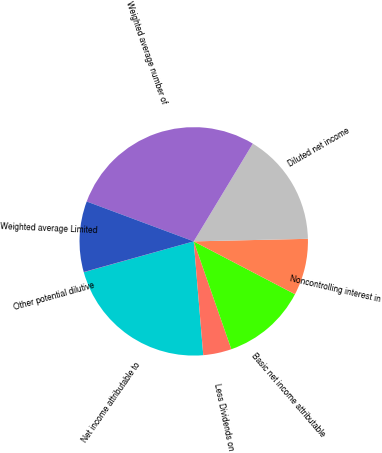Convert chart. <chart><loc_0><loc_0><loc_500><loc_500><pie_chart><fcel>Net income attributable to<fcel>Less Dividends on<fcel>Basic net income attributable<fcel>Noncontrolling interest in<fcel>Diluted net income<fcel>Weighted average number of<fcel>Weighted average Limited<fcel>Other potential dilutive<nl><fcel>21.98%<fcel>4.01%<fcel>12.0%<fcel>8.01%<fcel>15.99%<fcel>27.97%<fcel>10.0%<fcel>0.02%<nl></chart> 